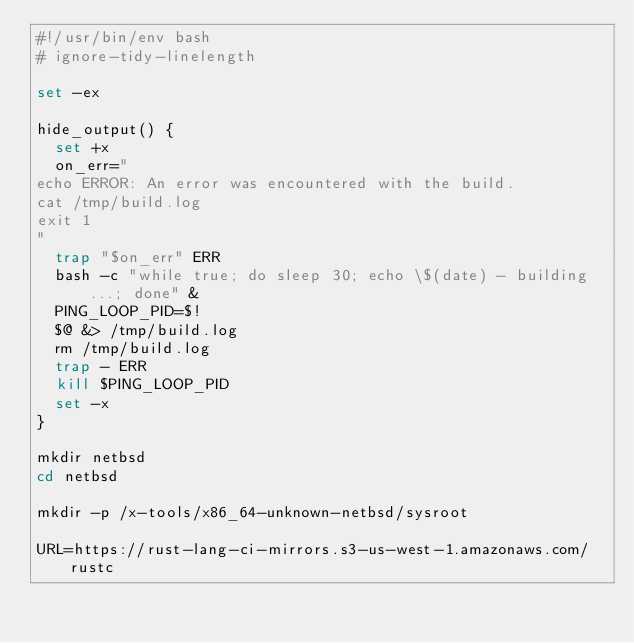Convert code to text. <code><loc_0><loc_0><loc_500><loc_500><_Bash_>#!/usr/bin/env bash
# ignore-tidy-linelength

set -ex

hide_output() {
  set +x
  on_err="
echo ERROR: An error was encountered with the build.
cat /tmp/build.log
exit 1
"
  trap "$on_err" ERR
  bash -c "while true; do sleep 30; echo \$(date) - building ...; done" &
  PING_LOOP_PID=$!
  $@ &> /tmp/build.log
  rm /tmp/build.log
  trap - ERR
  kill $PING_LOOP_PID
  set -x
}

mkdir netbsd
cd netbsd

mkdir -p /x-tools/x86_64-unknown-netbsd/sysroot

URL=https://rust-lang-ci-mirrors.s3-us-west-1.amazonaws.com/rustc
</code> 